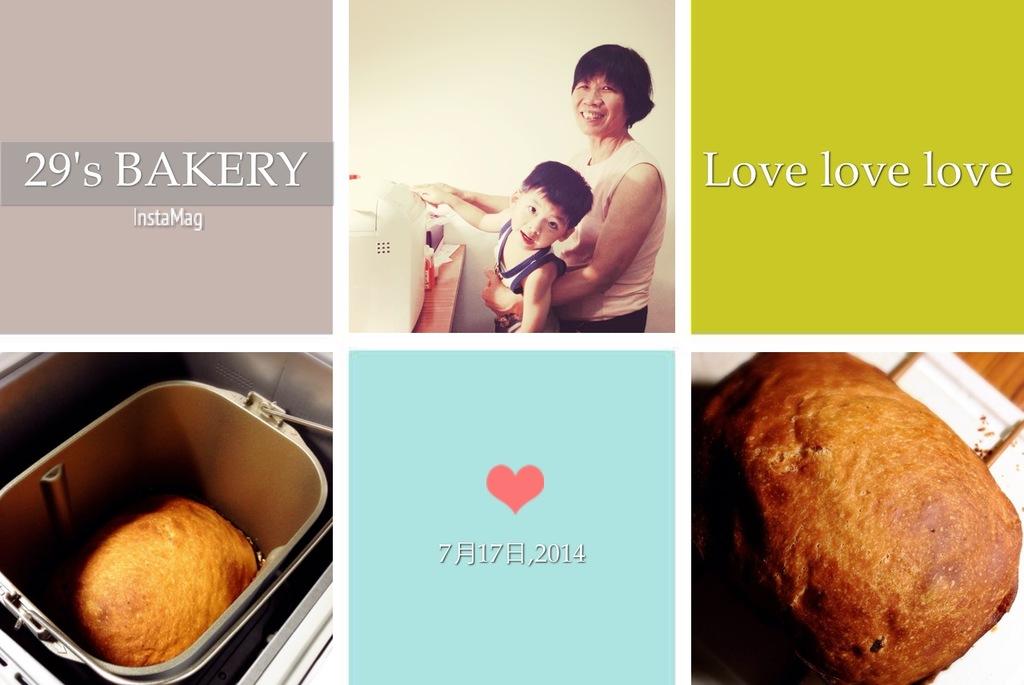What number is featured in the name of the bakery?
Your answer should be compact. 29. What three repeated words are in the top right?
Give a very brief answer. Love love love. 